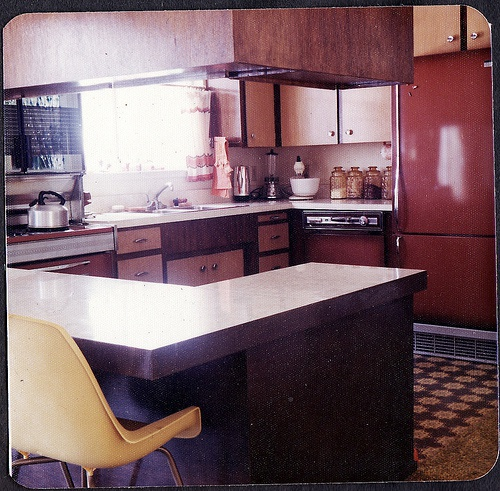Describe the objects in this image and their specific colors. I can see dining table in black, lightgray, darkgray, and purple tones, refrigerator in black, maroon, and brown tones, chair in black, tan, and lightgray tones, oven in black, darkgray, and purple tones, and sink in black, lightgray, darkgray, and pink tones in this image. 